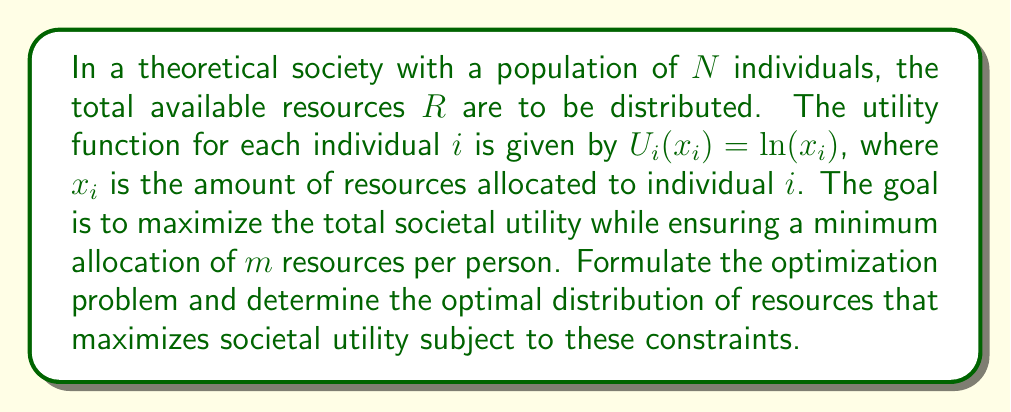Provide a solution to this math problem. To solve this problem, we'll use the method of Lagrange multipliers for constrained optimization. Let's break it down step-by-step:

1) The objective function (total societal utility) is:

   $$F(x_1, x_2, ..., x_N) = \sum_{i=1}^N U_i(x_i) = \sum_{i=1}^N \ln(x_i)$$

2) We have two constraints:
   a) The sum of all allocations must equal the total resources: $\sum_{i=1}^N x_i = R$
   b) Each individual must receive at least $m$ resources: $x_i \geq m$ for all $i$

3) We can formulate the Lagrangian:

   $$L(x_1, ..., x_N, \lambda) = \sum_{i=1}^N \ln(x_i) - \lambda(\sum_{i=1}^N x_i - R)$$

   Note: We don't include the inequality constraint in the Lagrangian yet.

4) Taking partial derivatives and setting them to zero:

   $$\frac{\partial L}{\partial x_i} = \frac{1}{x_i} - \lambda = 0$$
   $$\frac{\partial L}{\partial \lambda} = R - \sum_{i=1}^N x_i = 0$$

5) From the first equation, we get $x_i = \frac{1}{\lambda}$ for all $i$. This means all individuals should receive equal allocation.

6) Substituting this into the second equation:

   $$R - N\cdot\frac{1}{\lambda} = 0$$

   Solving for $\lambda$: $\lambda = \frac{N}{R}$

7) Therefore, the optimal allocation for each individual is:

   $$x_i = \frac{R}{N}$$

8) We need to check if this satisfies the minimum allocation constraint:

   If $\frac{R}{N} \geq m$, then this is our final answer.
   If $\frac{R}{N} < m$, we need to adjust our solution.

9) In the case where $\frac{R}{N} < m$, we allocate $m$ to as many individuals as possible, and the remaining resources (if any) to one partial allocation:

   Number of full allocations: $\lfloor\frac{R}{m}\rfloor$
   Partial allocation: $R - m\cdot\lfloor\frac{R}{m}\rfloor$

Thus, the optimal distribution depends on whether $\frac{R}{N} \geq m$ or not.
Answer: The optimal distribution of resources is:

If $\frac{R}{N} \geq m$:
$$x_i = \frac{R}{N} \text{ for all } i$$

If $\frac{R}{N} < m$:
$$x_i = \begin{cases} 
m & \text{for } i = 1, 2, ..., \lfloor\frac{R}{m}\rfloor \\
R - m\cdot\lfloor\frac{R}{m}\rfloor & \text{for } i = \lfloor\frac{R}{m}\rfloor + 1 \\
0 & \text{for } i > \lfloor\frac{R}{m}\rfloor + 1
\end{cases}$$ 